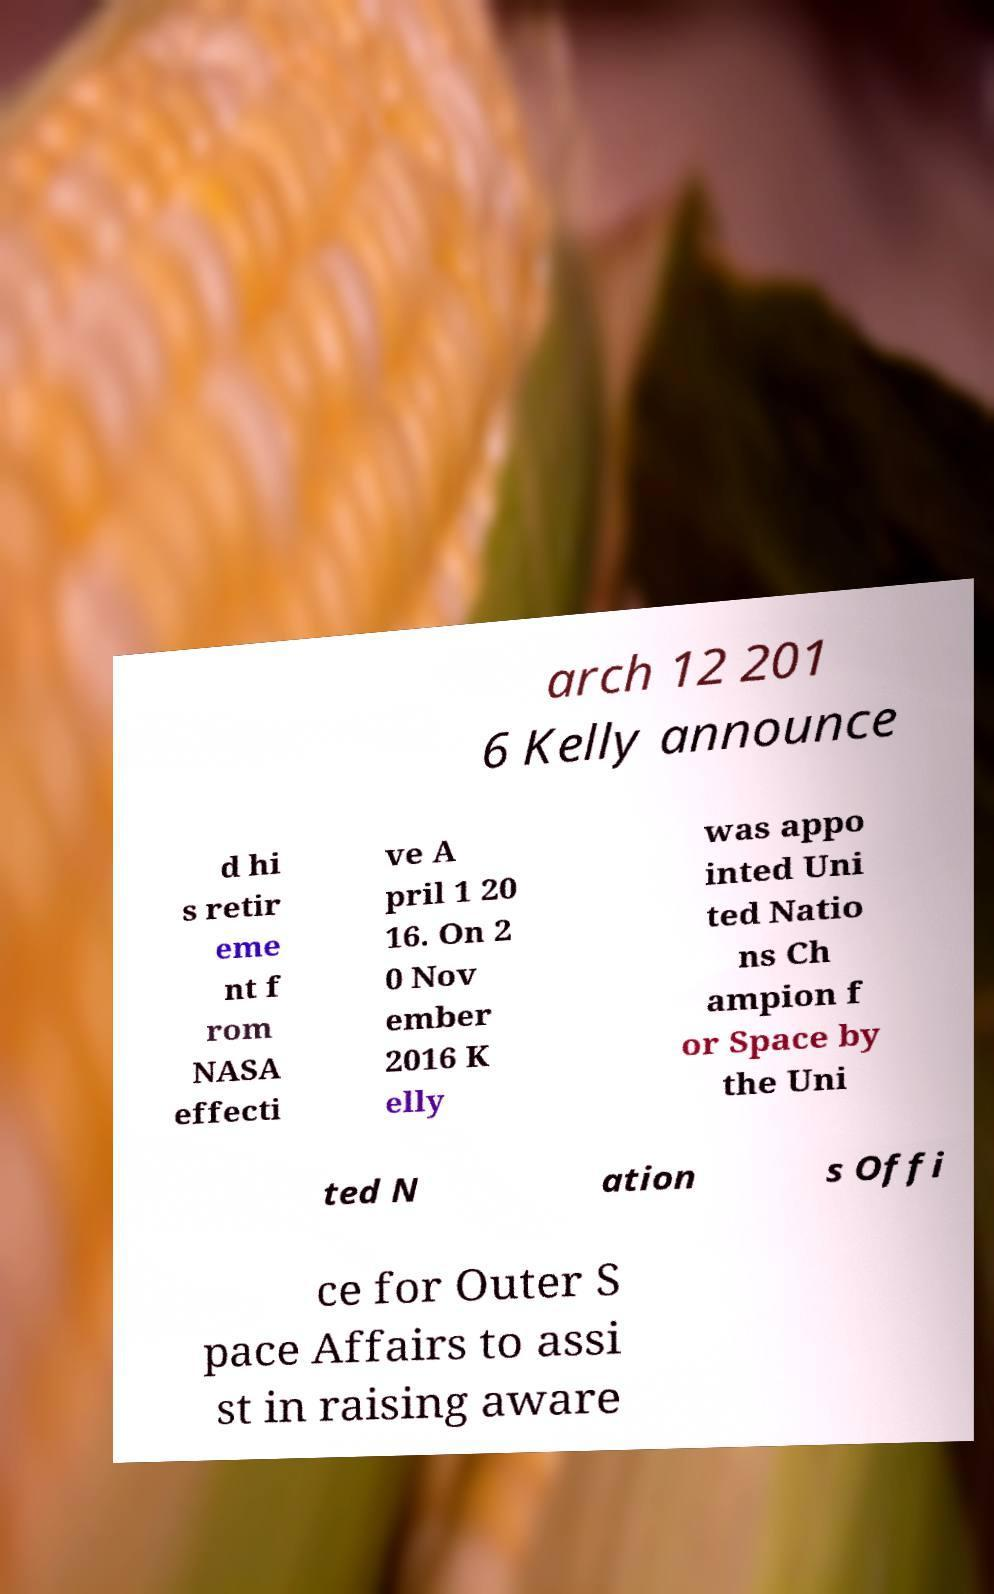What messages or text are displayed in this image? I need them in a readable, typed format. arch 12 201 6 Kelly announce d hi s retir eme nt f rom NASA effecti ve A pril 1 20 16. On 2 0 Nov ember 2016 K elly was appo inted Uni ted Natio ns Ch ampion f or Space by the Uni ted N ation s Offi ce for Outer S pace Affairs to assi st in raising aware 